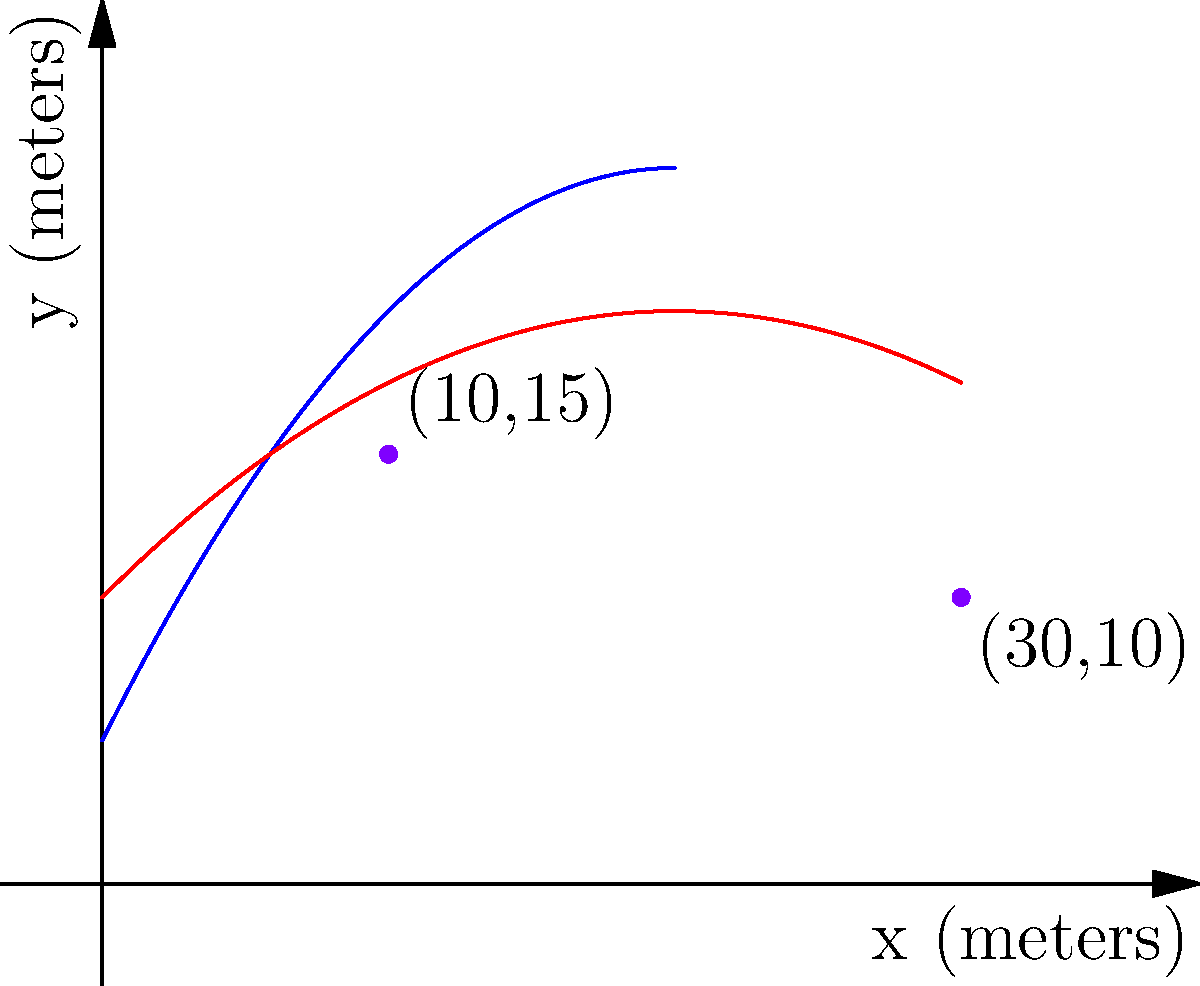In a ballistics analysis, two projectiles are fired with different initial velocities and angles. Their trajectories are modeled by the following equations:

Trajectory 1: $y = -0.05x^2 + 2x + 5$
Trajectory 2: $y = -0.025x^2 + x + 10$

Where $x$ and $y$ are measured in meters. Find the $x$-coordinates of the intersection points of these two trajectories. To find the intersection points, we need to solve the equation:

$-0.05x^2 + 2x + 5 = -0.025x^2 + x + 10$

Step 1: Rearrange the equation
$-0.05x^2 + 2x + 5 - (-0.025x^2 + x + 10) = 0$
$-0.025x^2 + x - 5 = 0$

Step 2: Multiply all terms by -40 to eliminate fractions
$x^2 - 40x + 200 = 0$

Step 3: Use the quadratic formula $x = \frac{-b \pm \sqrt{b^2 - 4ac}}{2a}$
$a = 1$, $b = -40$, $c = 200$

$x = \frac{40 \pm \sqrt{1600 - 800}}{2} = \frac{40 \pm \sqrt{800}}{2} = \frac{40 \pm 20\sqrt{2}}{2}$

Step 4: Simplify
$x = 20 \pm 10\sqrt{2}$

Step 5: Calculate the two solutions
$x_1 = 20 + 10\sqrt{2} \approx 34.14$ meters
$x_2 = 20 - 10\sqrt{2} \approx 5.86$ meters

The intersection points are at approximately 5.86 meters and 34.14 meters on the x-axis.
Answer: $x \approx 5.86$ meters and $x \approx 34.14$ meters 